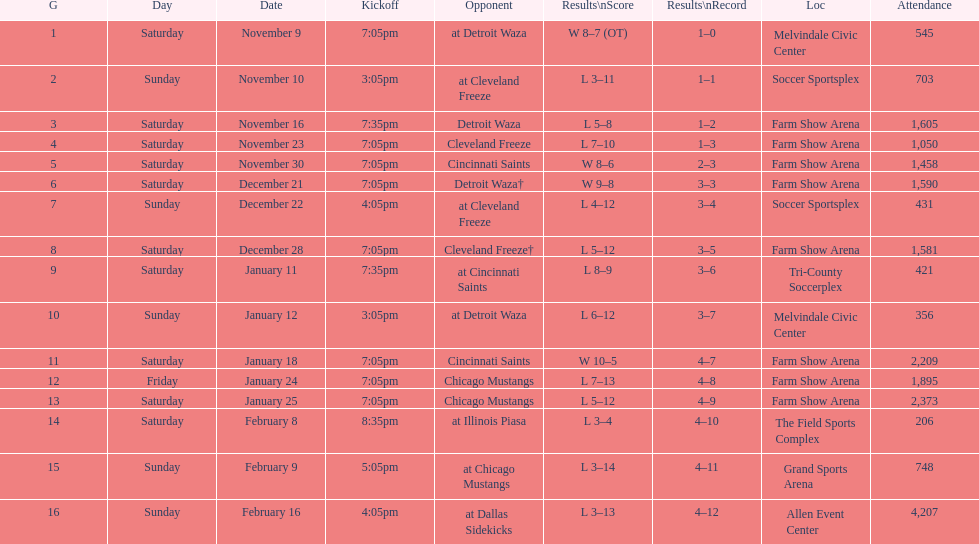Who was the first opponent on this list? Detroit Waza. 